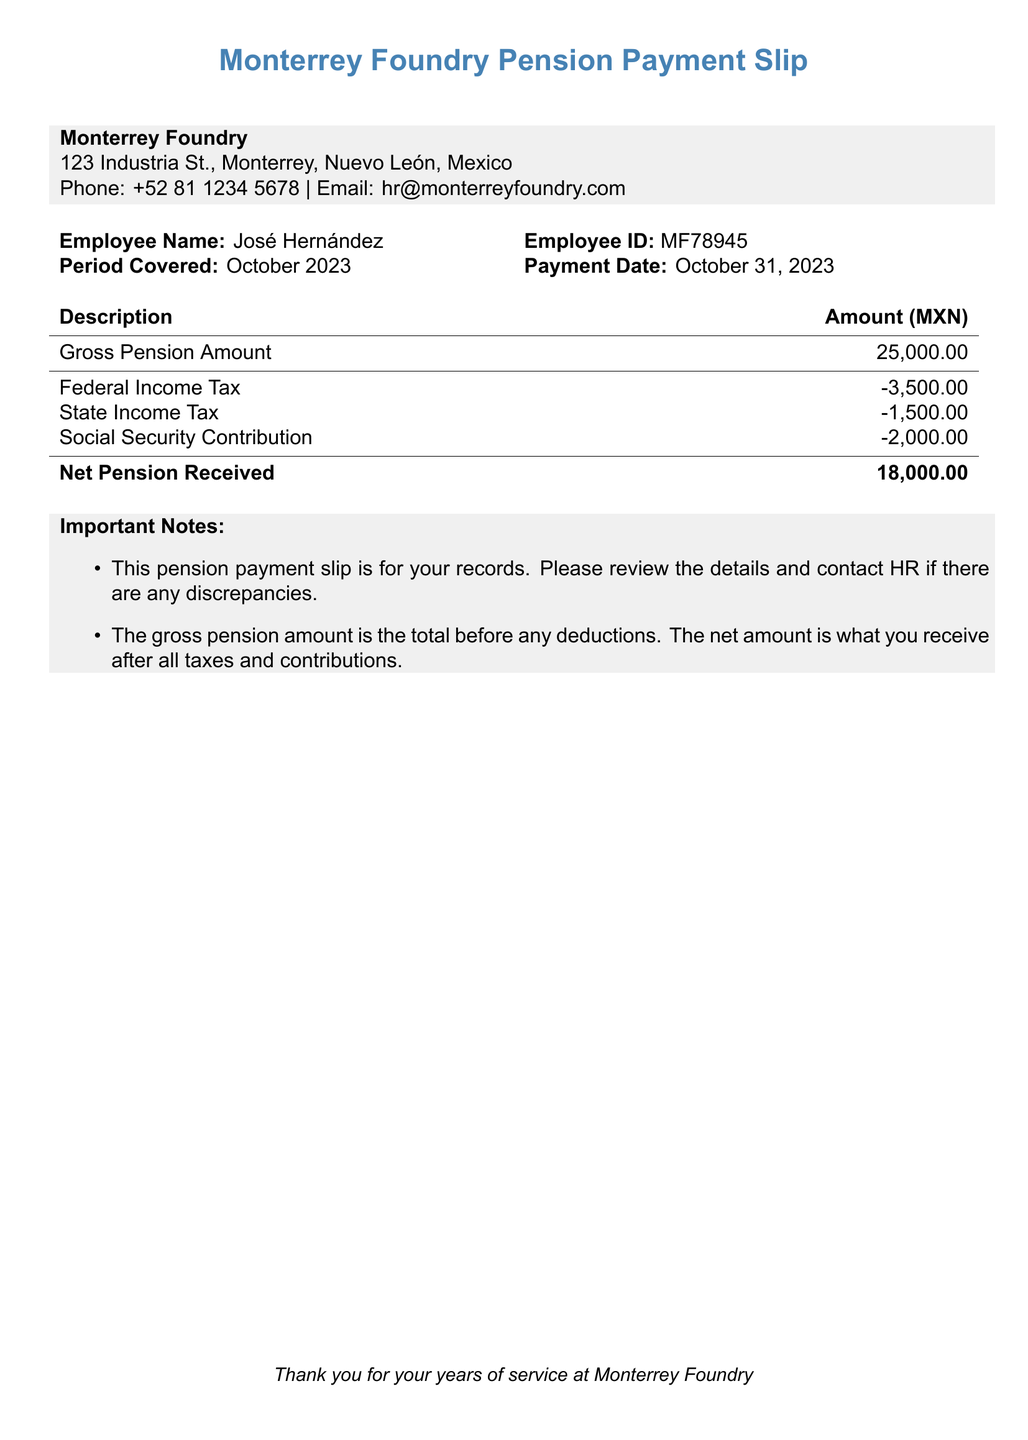What is the employee name? The employee name is listed at the top of the document under the Employee Name section.
Answer: José Hernández What is the payment date? The payment date is mentioned in the document under the Payment Date section.
Answer: October 31, 2023 What is the gross pension amount? The gross pension amount is provided in the table under the Description and Amount columns.
Answer: 25,000.00 What is the total amount of taxes withheld? The total amount of taxes withheld includes federal income tax, state income tax, and social security contribution, calculated as -3,500.00 -1,500.00 -2,000.00.
Answer: 7,000.00 What is the net pension received? The net pension received is explicitly stated in the table under the Amount column as the final figure.
Answer: 18,000.00 What period is covered by this payment slip? The period covered is specified in the document in the corresponding section.
Answer: October 2023 What is the employee ID? The employee ID is provided next to the Employee ID section in the document.
Answer: MF78945 What is the phone number for Monterrey Foundry? The phone number for Monterrey Foundry is listed in the contact information section.
Answer: +52 81 1234 5678 What is the social security contribution amount? The social security contribution amount is directly mentioned in the taxes withheld section of the document.
Answer: -2,000.00 